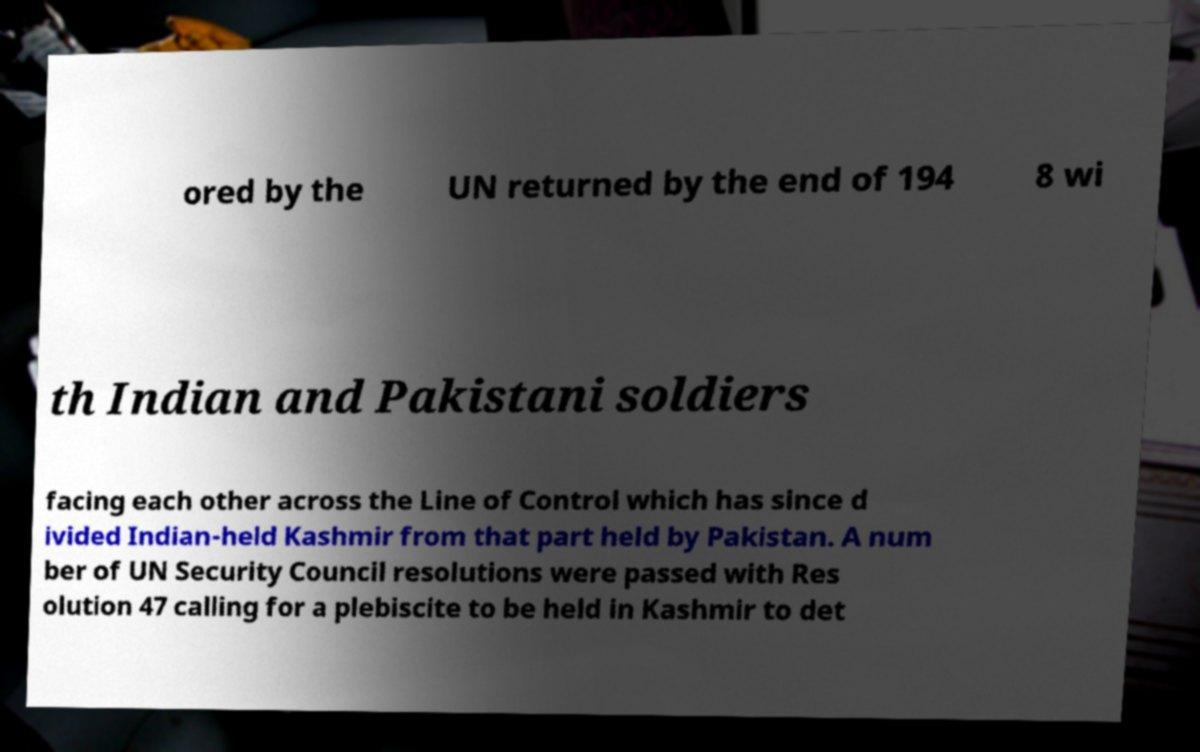For documentation purposes, I need the text within this image transcribed. Could you provide that? ored by the UN returned by the end of 194 8 wi th Indian and Pakistani soldiers facing each other across the Line of Control which has since d ivided Indian-held Kashmir from that part held by Pakistan. A num ber of UN Security Council resolutions were passed with Res olution 47 calling for a plebiscite to be held in Kashmir to det 